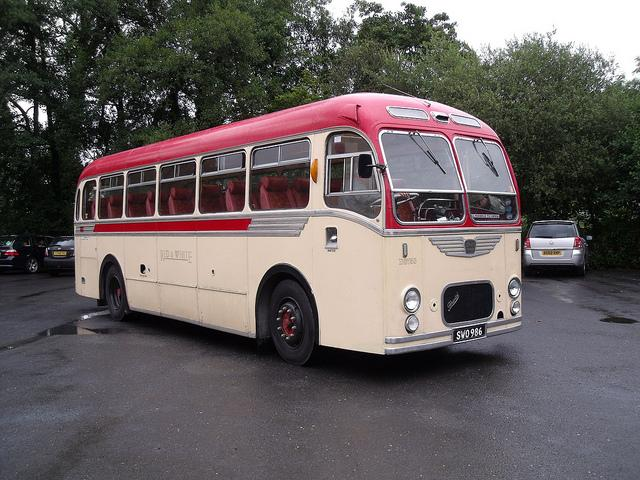What is the purpose of this vehicle? Please explain your reasoning. carry passengers. The purpose is carrying people. 